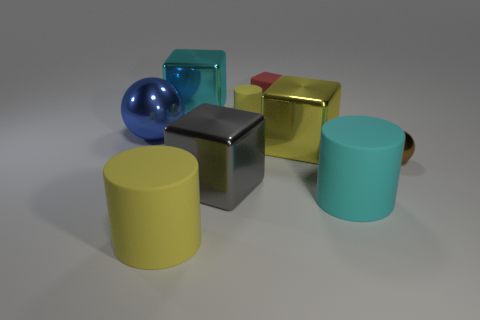Is there a thing of the same color as the small matte cylinder?
Your answer should be very brief. Yes. Is the number of big shiny cubes greater than the number of big cyan rubber objects?
Provide a short and direct response. Yes. What number of objects are shiny cubes in front of the tiny metallic sphere or cylinders that are on the left side of the tiny red thing?
Provide a succinct answer. 3. What is the color of the rubber cube that is the same size as the brown shiny ball?
Keep it short and to the point. Red. Is the small cylinder made of the same material as the tiny cube?
Your answer should be very brief. Yes. What material is the thing that is in front of the large rubber cylinder on the right side of the yellow cube?
Your answer should be very brief. Rubber. Are there more cyan rubber cylinders that are behind the tiny red rubber block than tiny rubber cubes?
Keep it short and to the point. No. What number of other objects are there of the same size as the gray object?
Make the answer very short. 5. Do the small matte cube and the small rubber cylinder have the same color?
Make the answer very short. No. What color is the metal object on the left side of the cylinder in front of the large rubber thing that is on the right side of the small red block?
Keep it short and to the point. Blue. 